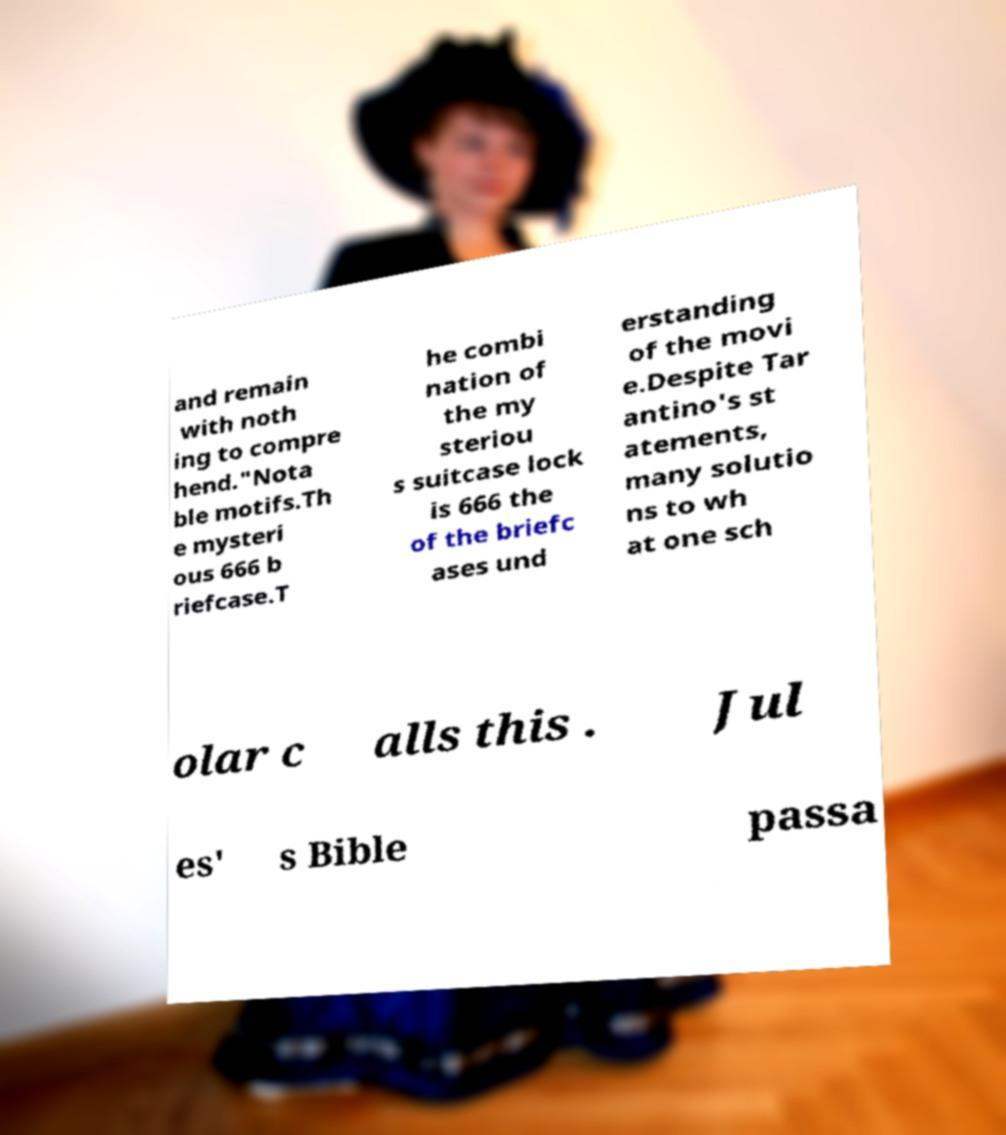Can you read and provide the text displayed in the image?This photo seems to have some interesting text. Can you extract and type it out for me? and remain with noth ing to compre hend."Nota ble motifs.Th e mysteri ous 666 b riefcase.T he combi nation of the my steriou s suitcase lock is 666 the of the briefc ases und erstanding of the movi e.Despite Tar antino's st atements, many solutio ns to wh at one sch olar c alls this . Jul es' s Bible passa 